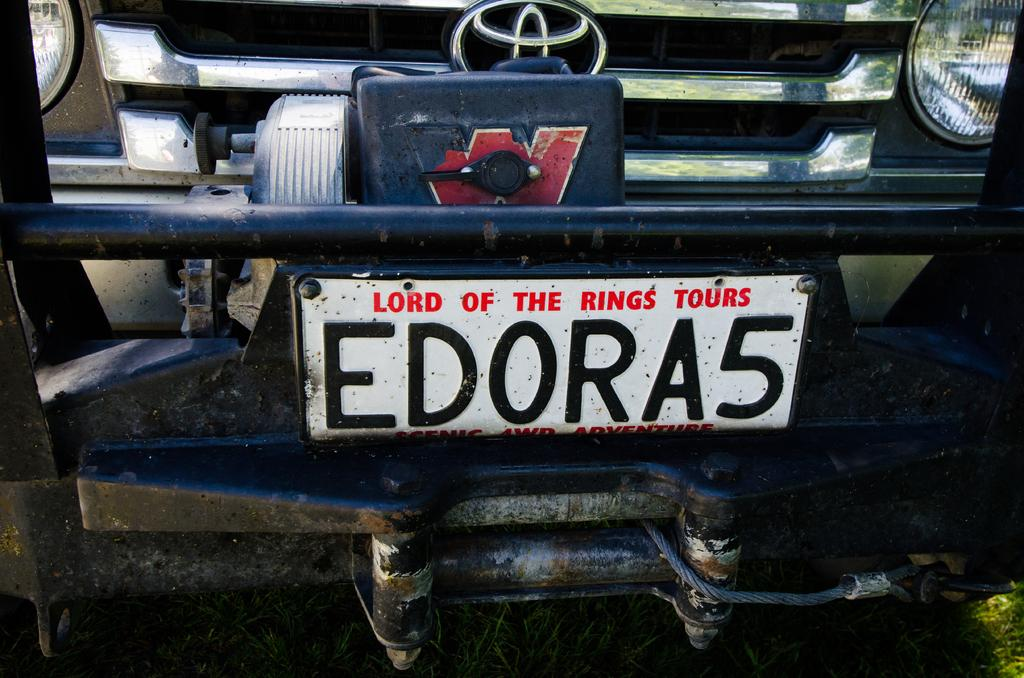What is the main subject of the picture? The main subject of the picture is a vehicle. Can you describe any specific features of the vehicle? Yes, the vehicle has a number plate. What type of secretary can be seen dusting the vehicle in the image? There is no secretary or dusting activity present in the image; it only features a vehicle with a number plate. What type of agreement is being signed by the people in the image? There are no people or agreements present in the image; it only features a vehicle with a number plate. 